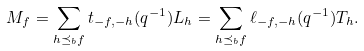Convert formula to latex. <formula><loc_0><loc_0><loc_500><loc_500>M _ { f } = \sum _ { h \preceq _ { b } f } t _ { - f , - h } ( q ^ { - 1 } ) L _ { h } = \sum _ { h \preceq _ { b } f } \ell _ { - f , - h } ( q ^ { - 1 } ) T _ { h } .</formula> 